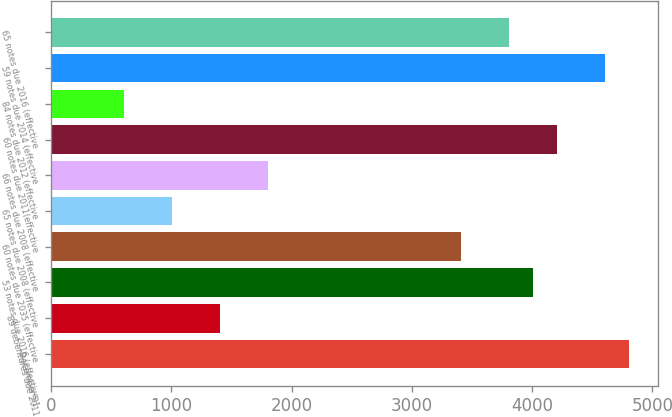Convert chart to OTSL. <chart><loc_0><loc_0><loc_500><loc_500><bar_chart><fcel>December 31<fcel>89 debentures due 2011<fcel>53 notes due 2016 (effective<fcel>60 notes due 2035 (effective<fcel>65 notes due 2008 (effective<fcel>66 notes due 2008 (effective<fcel>60 notes due 2011(effective<fcel>84 notes due 2012 (effective<fcel>59 notes due 2014 (effective<fcel>65 notes due 2016 (effective<nl><fcel>4807.4<fcel>1405.7<fcel>4007<fcel>3406.7<fcel>1005.5<fcel>1805.9<fcel>4207.1<fcel>605.3<fcel>4607.3<fcel>3806.9<nl></chart> 